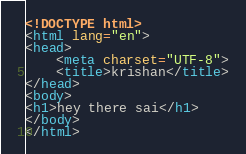<code> <loc_0><loc_0><loc_500><loc_500><_HTML_><!DOCTYPE html>
<html lang="en">
<head>
    <meta charset="UTF-8">
    <title>krishan</title>
</head>
<body>
<h1>hey there sai</h1>
</body>
</html></code> 